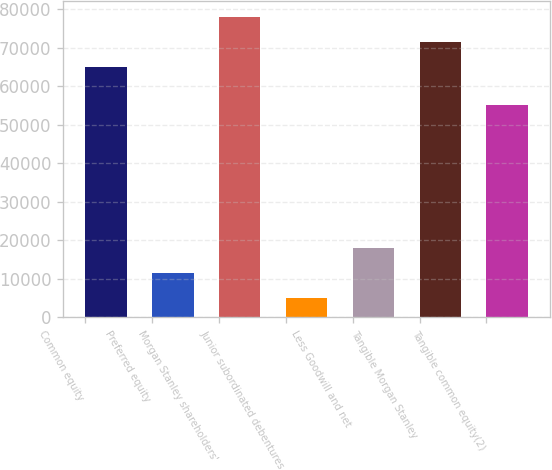<chart> <loc_0><loc_0><loc_500><loc_500><bar_chart><fcel>Common equity<fcel>Preferred equity<fcel>Morgan Stanley shareholders'<fcel>Junior subordinated debentures<fcel>Less Goodwill and net<fcel>Tangible Morgan Stanley<fcel>Tangible common equity(2)<nl><fcel>64880<fcel>11471.2<fcel>78086.4<fcel>4868<fcel>18074.4<fcel>71483.2<fcel>55138<nl></chart> 